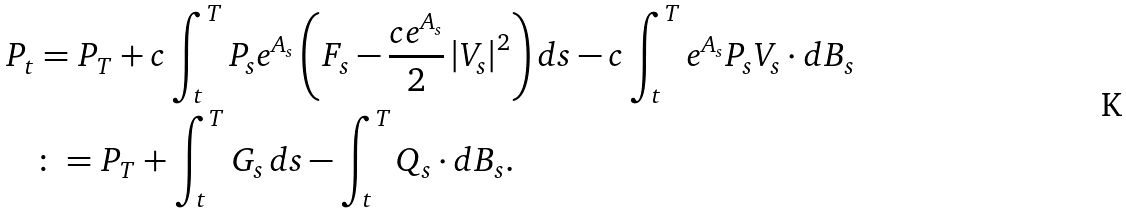<formula> <loc_0><loc_0><loc_500><loc_500>P _ { t } & = P _ { T } + c \int _ { t } ^ { T } P _ { s } e ^ { A _ { s } } \left ( F _ { s } - \frac { c e ^ { A _ { s } } } { 2 } \left | V _ { s } \right | ^ { 2 } \right ) d s - c \int _ { t } ^ { T } e ^ { A _ { s } } P _ { s } V _ { s } \cdot d B _ { s } \\ & \colon = P _ { T } + \int _ { t } ^ { T } G _ { s } \, d s - \int _ { t } ^ { T } Q _ { s } \cdot d B _ { s } .</formula> 